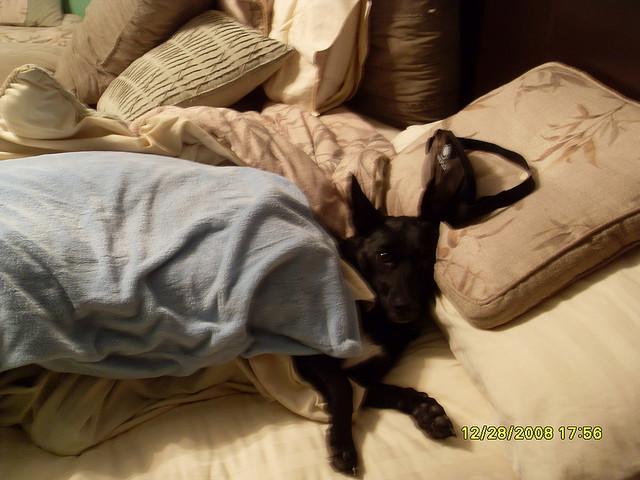Where is the dog?
Write a very short answer. On bed. What type of dog is this?
Concise answer only. Large. What year was the picture taken?
Quick response, please. 2008. Is the dog sleeping?
Write a very short answer. No. 